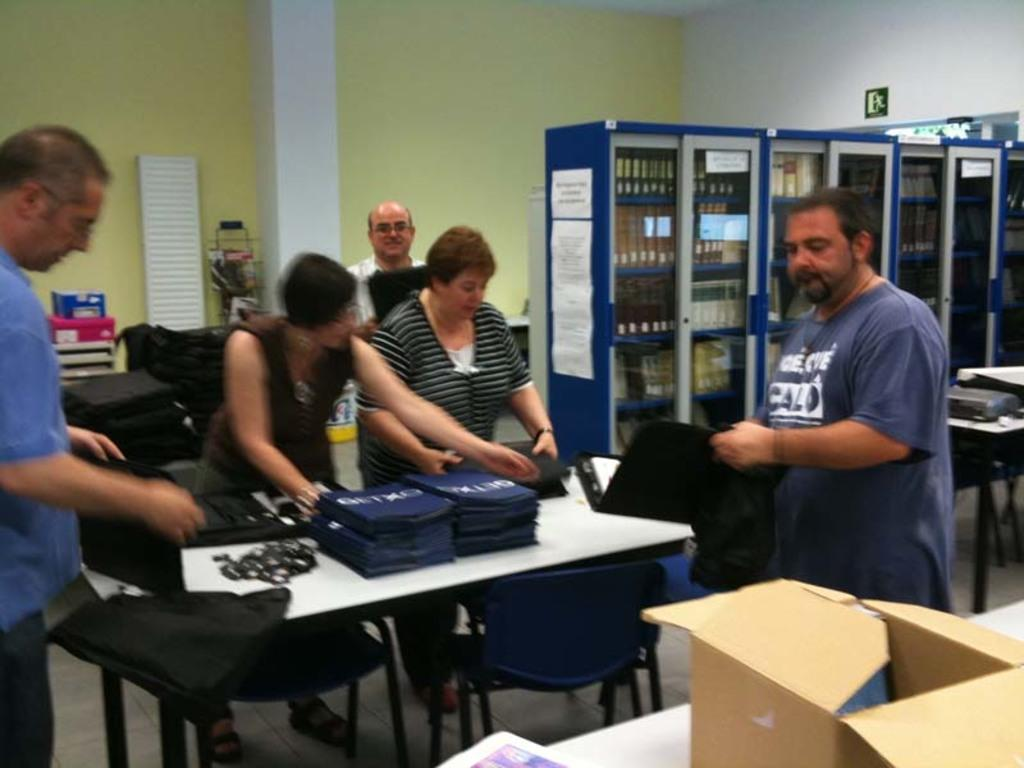What can be seen in the image involving people? There are people standing in the image. What object is present in the image that is not related to people? There is a box in the image. What type of furniture is visible in the image? There are tables and chairs in the image. What is a person holding in the image? A person is holding a file in the image. What type of veil is being used to cover the competition in the image? There is no veil or competition present in the image. 